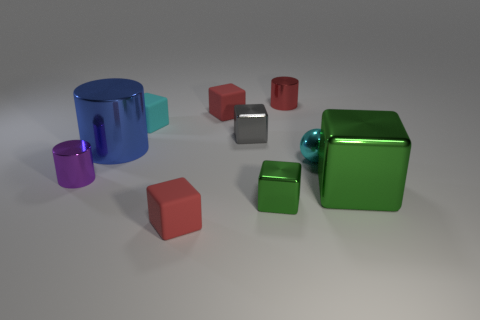Are there any green metal blocks in front of the big green metallic object?
Your answer should be compact. Yes. The metallic cube that is both to the left of the small red cylinder and in front of the gray object is what color?
Your answer should be very brief. Green. There is a metallic thing that is the same color as the large cube; what is its shape?
Give a very brief answer. Cube. How big is the purple shiny thing that is in front of the small red shiny cylinder that is behind the small cyan matte cube?
Your answer should be compact. Small. How many cubes are either purple objects or small matte things?
Provide a succinct answer. 3. There is a metal ball that is the same size as the purple object; what is its color?
Make the answer very short. Cyan. There is a tiny red rubber thing on the left side of the red block behind the tiny cyan matte cube; what is its shape?
Provide a succinct answer. Cube. There is a metal cylinder to the left of the blue object; is its size the same as the gray block?
Keep it short and to the point. Yes. What number of other objects are there of the same material as the small ball?
Provide a succinct answer. 6. How many green objects are large cylinders or blocks?
Keep it short and to the point. 2. 